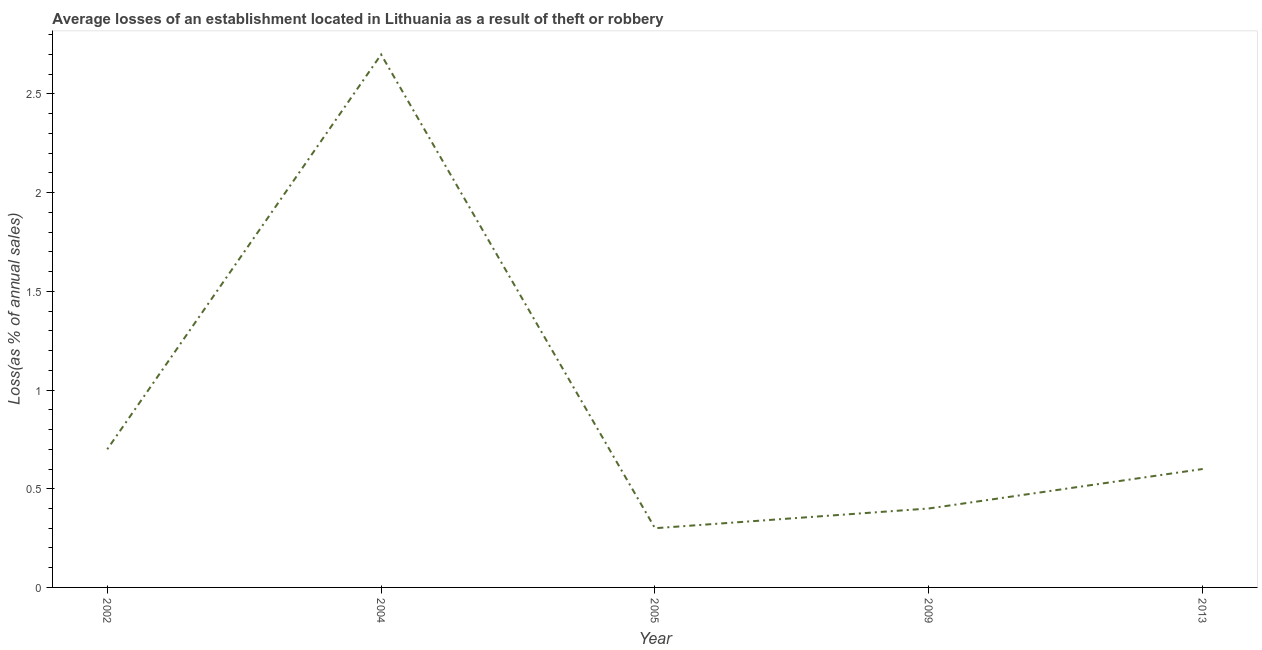What is the sum of the losses due to theft?
Your answer should be very brief. 4.7. What is the difference between the losses due to theft in 2002 and 2005?
Your answer should be compact. 0.4. What is the average losses due to theft per year?
Your answer should be very brief. 0.94. What is the median losses due to theft?
Make the answer very short. 0.6. What is the ratio of the losses due to theft in 2009 to that in 2013?
Offer a very short reply. 0.67. Is the losses due to theft in 2002 less than that in 2013?
Your answer should be compact. No. What is the difference between the highest and the second highest losses due to theft?
Give a very brief answer. 2. What is the difference between the highest and the lowest losses due to theft?
Provide a succinct answer. 2.4. Does the losses due to theft monotonically increase over the years?
Make the answer very short. No. How many lines are there?
Provide a succinct answer. 1. What is the difference between two consecutive major ticks on the Y-axis?
Provide a succinct answer. 0.5. Does the graph contain any zero values?
Your response must be concise. No. Does the graph contain grids?
Make the answer very short. No. What is the title of the graph?
Offer a terse response. Average losses of an establishment located in Lithuania as a result of theft or robbery. What is the label or title of the X-axis?
Keep it short and to the point. Year. What is the label or title of the Y-axis?
Ensure brevity in your answer.  Loss(as % of annual sales). What is the Loss(as % of annual sales) of 2004?
Your response must be concise. 2.7. What is the difference between the Loss(as % of annual sales) in 2002 and 2004?
Offer a terse response. -2. What is the difference between the Loss(as % of annual sales) in 2002 and 2005?
Ensure brevity in your answer.  0.4. What is the difference between the Loss(as % of annual sales) in 2004 and 2005?
Provide a succinct answer. 2.4. What is the difference between the Loss(as % of annual sales) in 2004 and 2013?
Provide a succinct answer. 2.1. What is the difference between the Loss(as % of annual sales) in 2005 and 2009?
Offer a very short reply. -0.1. What is the difference between the Loss(as % of annual sales) in 2005 and 2013?
Keep it short and to the point. -0.3. What is the ratio of the Loss(as % of annual sales) in 2002 to that in 2004?
Your answer should be very brief. 0.26. What is the ratio of the Loss(as % of annual sales) in 2002 to that in 2005?
Offer a very short reply. 2.33. What is the ratio of the Loss(as % of annual sales) in 2002 to that in 2013?
Your answer should be compact. 1.17. What is the ratio of the Loss(as % of annual sales) in 2004 to that in 2009?
Give a very brief answer. 6.75. What is the ratio of the Loss(as % of annual sales) in 2009 to that in 2013?
Offer a terse response. 0.67. 